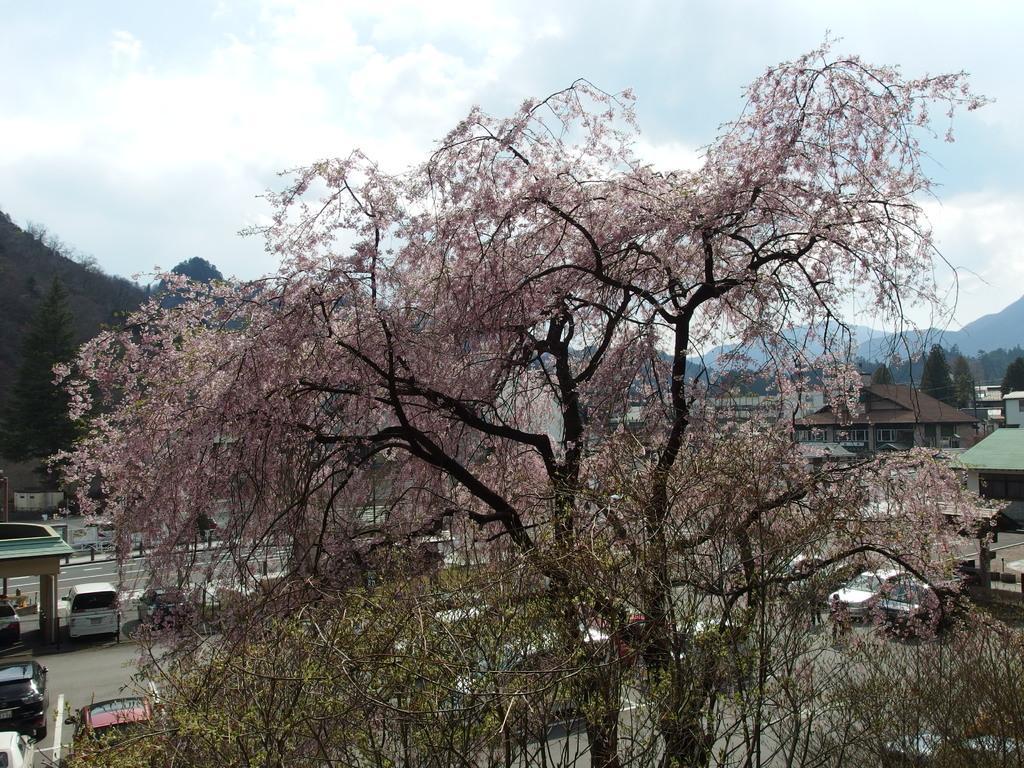How would you summarize this image in a sentence or two? In this picture we can see few trees and vehicles on the road, in the background we can find few houses, hills and clouds. 